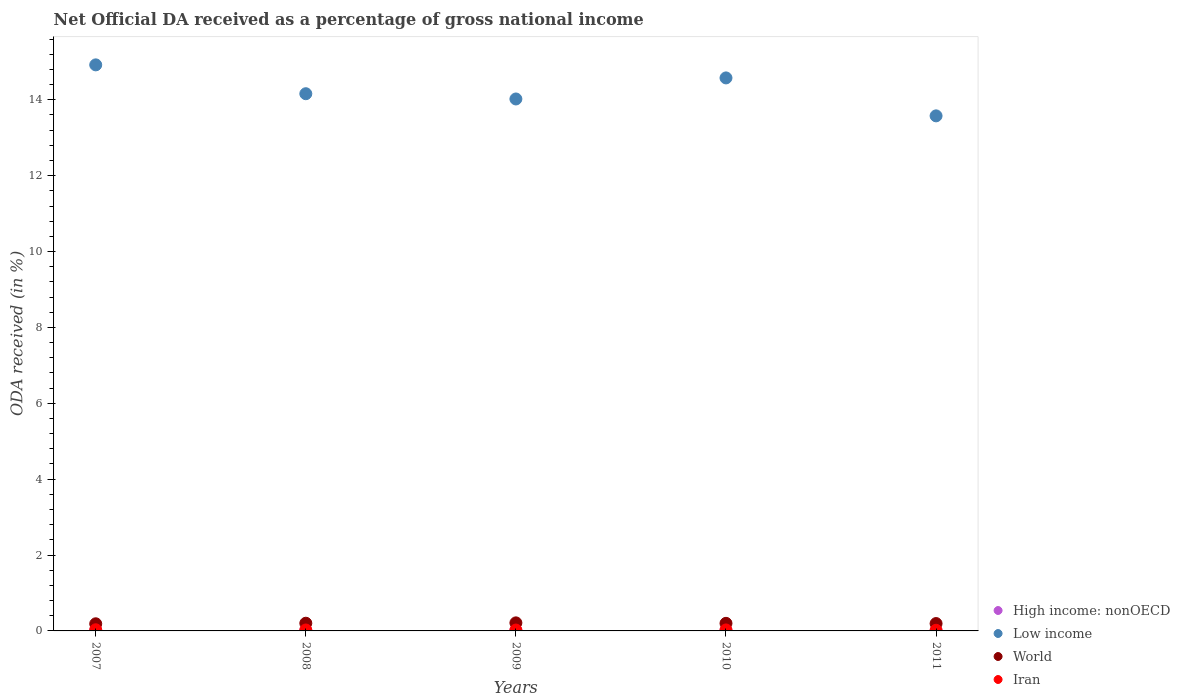What is the net official DA received in World in 2011?
Offer a very short reply. 0.19. Across all years, what is the maximum net official DA received in World?
Ensure brevity in your answer.  0.21. Across all years, what is the minimum net official DA received in High income: nonOECD?
Your response must be concise. 0. In which year was the net official DA received in Low income minimum?
Give a very brief answer. 2011. What is the total net official DA received in Low income in the graph?
Offer a very short reply. 71.26. What is the difference between the net official DA received in World in 2008 and that in 2011?
Your answer should be very brief. 0.01. What is the difference between the net official DA received in High income: nonOECD in 2011 and the net official DA received in World in 2009?
Give a very brief answer. -0.21. What is the average net official DA received in High income: nonOECD per year?
Ensure brevity in your answer.  0.01. In the year 2011, what is the difference between the net official DA received in Low income and net official DA received in World?
Make the answer very short. 13.38. What is the ratio of the net official DA received in Low income in 2010 to that in 2011?
Provide a succinct answer. 1.07. What is the difference between the highest and the second highest net official DA received in Iran?
Offer a very short reply. 0. What is the difference between the highest and the lowest net official DA received in World?
Your answer should be very brief. 0.02. In how many years, is the net official DA received in Low income greater than the average net official DA received in Low income taken over all years?
Offer a terse response. 2. Is it the case that in every year, the sum of the net official DA received in Iran and net official DA received in World  is greater than the net official DA received in High income: nonOECD?
Your answer should be compact. Yes. Does the net official DA received in World monotonically increase over the years?
Your answer should be compact. No. Is the net official DA received in High income: nonOECD strictly greater than the net official DA received in Low income over the years?
Your response must be concise. No. How many years are there in the graph?
Make the answer very short. 5. What is the difference between two consecutive major ticks on the Y-axis?
Provide a short and direct response. 2. Are the values on the major ticks of Y-axis written in scientific E-notation?
Your answer should be very brief. No. How many legend labels are there?
Offer a terse response. 4. How are the legend labels stacked?
Ensure brevity in your answer.  Vertical. What is the title of the graph?
Keep it short and to the point. Net Official DA received as a percentage of gross national income. What is the label or title of the X-axis?
Provide a succinct answer. Years. What is the label or title of the Y-axis?
Offer a terse response. ODA received (in %). What is the ODA received (in %) of High income: nonOECD in 2007?
Your answer should be compact. 0.01. What is the ODA received (in %) of Low income in 2007?
Your answer should be very brief. 14.92. What is the ODA received (in %) of World in 2007?
Provide a succinct answer. 0.19. What is the ODA received (in %) of Iran in 2007?
Offer a very short reply. 0.03. What is the ODA received (in %) in High income: nonOECD in 2008?
Give a very brief answer. 0.01. What is the ODA received (in %) in Low income in 2008?
Your response must be concise. 14.16. What is the ODA received (in %) of World in 2008?
Your response must be concise. 0.2. What is the ODA received (in %) of Iran in 2008?
Provide a succinct answer. 0.02. What is the ODA received (in %) of High income: nonOECD in 2009?
Ensure brevity in your answer.  0.02. What is the ODA received (in %) of Low income in 2009?
Offer a terse response. 14.02. What is the ODA received (in %) of World in 2009?
Offer a terse response. 0.21. What is the ODA received (in %) of Iran in 2009?
Offer a very short reply. 0.02. What is the ODA received (in %) in High income: nonOECD in 2010?
Offer a terse response. 0.01. What is the ODA received (in %) in Low income in 2010?
Provide a short and direct response. 14.58. What is the ODA received (in %) in World in 2010?
Your answer should be compact. 0.2. What is the ODA received (in %) of Iran in 2010?
Make the answer very short. 0.03. What is the ODA received (in %) of High income: nonOECD in 2011?
Make the answer very short. 0. What is the ODA received (in %) in Low income in 2011?
Keep it short and to the point. 13.58. What is the ODA received (in %) of World in 2011?
Make the answer very short. 0.19. What is the ODA received (in %) of Iran in 2011?
Your answer should be very brief. 0.02. Across all years, what is the maximum ODA received (in %) in High income: nonOECD?
Your answer should be very brief. 0.02. Across all years, what is the maximum ODA received (in %) in Low income?
Your answer should be very brief. 14.92. Across all years, what is the maximum ODA received (in %) of World?
Offer a very short reply. 0.21. Across all years, what is the maximum ODA received (in %) of Iran?
Provide a short and direct response. 0.03. Across all years, what is the minimum ODA received (in %) in High income: nonOECD?
Ensure brevity in your answer.  0. Across all years, what is the minimum ODA received (in %) of Low income?
Ensure brevity in your answer.  13.58. Across all years, what is the minimum ODA received (in %) in World?
Ensure brevity in your answer.  0.19. Across all years, what is the minimum ODA received (in %) in Iran?
Offer a very short reply. 0.02. What is the total ODA received (in %) in High income: nonOECD in the graph?
Offer a very short reply. 0.06. What is the total ODA received (in %) in Low income in the graph?
Ensure brevity in your answer.  71.26. What is the total ODA received (in %) in World in the graph?
Offer a very short reply. 1. What is the total ODA received (in %) of Iran in the graph?
Provide a succinct answer. 0.12. What is the difference between the ODA received (in %) of High income: nonOECD in 2007 and that in 2008?
Provide a succinct answer. 0. What is the difference between the ODA received (in %) in Low income in 2007 and that in 2008?
Ensure brevity in your answer.  0.76. What is the difference between the ODA received (in %) in World in 2007 and that in 2008?
Keep it short and to the point. -0.01. What is the difference between the ODA received (in %) in Iran in 2007 and that in 2008?
Offer a terse response. 0.01. What is the difference between the ODA received (in %) of High income: nonOECD in 2007 and that in 2009?
Keep it short and to the point. -0. What is the difference between the ODA received (in %) in Low income in 2007 and that in 2009?
Offer a very short reply. 0.9. What is the difference between the ODA received (in %) of World in 2007 and that in 2009?
Offer a very short reply. -0.02. What is the difference between the ODA received (in %) of Iran in 2007 and that in 2009?
Provide a succinct answer. 0.01. What is the difference between the ODA received (in %) of High income: nonOECD in 2007 and that in 2010?
Offer a very short reply. 0. What is the difference between the ODA received (in %) of Low income in 2007 and that in 2010?
Make the answer very short. 0.34. What is the difference between the ODA received (in %) in World in 2007 and that in 2010?
Provide a short and direct response. -0.01. What is the difference between the ODA received (in %) of Iran in 2007 and that in 2010?
Your answer should be very brief. 0. What is the difference between the ODA received (in %) in High income: nonOECD in 2007 and that in 2011?
Your response must be concise. 0.01. What is the difference between the ODA received (in %) of Low income in 2007 and that in 2011?
Your answer should be very brief. 1.34. What is the difference between the ODA received (in %) in World in 2007 and that in 2011?
Provide a succinct answer. -0.01. What is the difference between the ODA received (in %) in Iran in 2007 and that in 2011?
Provide a succinct answer. 0.01. What is the difference between the ODA received (in %) in High income: nonOECD in 2008 and that in 2009?
Ensure brevity in your answer.  -0. What is the difference between the ODA received (in %) in Low income in 2008 and that in 2009?
Provide a short and direct response. 0.14. What is the difference between the ODA received (in %) of World in 2008 and that in 2009?
Your response must be concise. -0.01. What is the difference between the ODA received (in %) in Iran in 2008 and that in 2009?
Your response must be concise. 0. What is the difference between the ODA received (in %) in High income: nonOECD in 2008 and that in 2010?
Provide a succinct answer. 0. What is the difference between the ODA received (in %) of Low income in 2008 and that in 2010?
Offer a very short reply. -0.42. What is the difference between the ODA received (in %) in World in 2008 and that in 2010?
Ensure brevity in your answer.  0. What is the difference between the ODA received (in %) in Iran in 2008 and that in 2010?
Ensure brevity in your answer.  -0. What is the difference between the ODA received (in %) in High income: nonOECD in 2008 and that in 2011?
Offer a very short reply. 0.01. What is the difference between the ODA received (in %) of Low income in 2008 and that in 2011?
Your answer should be very brief. 0.58. What is the difference between the ODA received (in %) in World in 2008 and that in 2011?
Provide a succinct answer. 0.01. What is the difference between the ODA received (in %) of Iran in 2008 and that in 2011?
Your response must be concise. 0.01. What is the difference between the ODA received (in %) of High income: nonOECD in 2009 and that in 2010?
Your answer should be very brief. 0. What is the difference between the ODA received (in %) in Low income in 2009 and that in 2010?
Provide a succinct answer. -0.56. What is the difference between the ODA received (in %) of World in 2009 and that in 2010?
Your answer should be very brief. 0.01. What is the difference between the ODA received (in %) in Iran in 2009 and that in 2010?
Offer a very short reply. -0. What is the difference between the ODA received (in %) of High income: nonOECD in 2009 and that in 2011?
Ensure brevity in your answer.  0.01. What is the difference between the ODA received (in %) of Low income in 2009 and that in 2011?
Your answer should be very brief. 0.45. What is the difference between the ODA received (in %) of World in 2009 and that in 2011?
Ensure brevity in your answer.  0.02. What is the difference between the ODA received (in %) in Iran in 2009 and that in 2011?
Your answer should be very brief. 0.01. What is the difference between the ODA received (in %) of High income: nonOECD in 2010 and that in 2011?
Your response must be concise. 0.01. What is the difference between the ODA received (in %) in World in 2010 and that in 2011?
Provide a short and direct response. 0.01. What is the difference between the ODA received (in %) in Iran in 2010 and that in 2011?
Make the answer very short. 0.01. What is the difference between the ODA received (in %) of High income: nonOECD in 2007 and the ODA received (in %) of Low income in 2008?
Give a very brief answer. -14.15. What is the difference between the ODA received (in %) in High income: nonOECD in 2007 and the ODA received (in %) in World in 2008?
Your answer should be compact. -0.19. What is the difference between the ODA received (in %) of High income: nonOECD in 2007 and the ODA received (in %) of Iran in 2008?
Your answer should be very brief. -0.01. What is the difference between the ODA received (in %) of Low income in 2007 and the ODA received (in %) of World in 2008?
Provide a succinct answer. 14.72. What is the difference between the ODA received (in %) of Low income in 2007 and the ODA received (in %) of Iran in 2008?
Ensure brevity in your answer.  14.9. What is the difference between the ODA received (in %) in World in 2007 and the ODA received (in %) in Iran in 2008?
Your answer should be compact. 0.16. What is the difference between the ODA received (in %) of High income: nonOECD in 2007 and the ODA received (in %) of Low income in 2009?
Your response must be concise. -14.01. What is the difference between the ODA received (in %) of High income: nonOECD in 2007 and the ODA received (in %) of World in 2009?
Provide a short and direct response. -0.2. What is the difference between the ODA received (in %) in High income: nonOECD in 2007 and the ODA received (in %) in Iran in 2009?
Offer a very short reply. -0.01. What is the difference between the ODA received (in %) of Low income in 2007 and the ODA received (in %) of World in 2009?
Offer a terse response. 14.71. What is the difference between the ODA received (in %) of Low income in 2007 and the ODA received (in %) of Iran in 2009?
Ensure brevity in your answer.  14.9. What is the difference between the ODA received (in %) in World in 2007 and the ODA received (in %) in Iran in 2009?
Offer a very short reply. 0.16. What is the difference between the ODA received (in %) of High income: nonOECD in 2007 and the ODA received (in %) of Low income in 2010?
Provide a short and direct response. -14.56. What is the difference between the ODA received (in %) of High income: nonOECD in 2007 and the ODA received (in %) of World in 2010?
Keep it short and to the point. -0.19. What is the difference between the ODA received (in %) in High income: nonOECD in 2007 and the ODA received (in %) in Iran in 2010?
Provide a short and direct response. -0.01. What is the difference between the ODA received (in %) of Low income in 2007 and the ODA received (in %) of World in 2010?
Provide a succinct answer. 14.72. What is the difference between the ODA received (in %) of Low income in 2007 and the ODA received (in %) of Iran in 2010?
Your response must be concise. 14.89. What is the difference between the ODA received (in %) in World in 2007 and the ODA received (in %) in Iran in 2010?
Your answer should be very brief. 0.16. What is the difference between the ODA received (in %) in High income: nonOECD in 2007 and the ODA received (in %) in Low income in 2011?
Keep it short and to the point. -13.56. What is the difference between the ODA received (in %) in High income: nonOECD in 2007 and the ODA received (in %) in World in 2011?
Your response must be concise. -0.18. What is the difference between the ODA received (in %) of High income: nonOECD in 2007 and the ODA received (in %) of Iran in 2011?
Keep it short and to the point. -0. What is the difference between the ODA received (in %) of Low income in 2007 and the ODA received (in %) of World in 2011?
Provide a succinct answer. 14.73. What is the difference between the ODA received (in %) of Low income in 2007 and the ODA received (in %) of Iran in 2011?
Provide a succinct answer. 14.9. What is the difference between the ODA received (in %) of World in 2007 and the ODA received (in %) of Iran in 2011?
Provide a short and direct response. 0.17. What is the difference between the ODA received (in %) in High income: nonOECD in 2008 and the ODA received (in %) in Low income in 2009?
Give a very brief answer. -14.01. What is the difference between the ODA received (in %) in High income: nonOECD in 2008 and the ODA received (in %) in World in 2009?
Ensure brevity in your answer.  -0.2. What is the difference between the ODA received (in %) in High income: nonOECD in 2008 and the ODA received (in %) in Iran in 2009?
Your answer should be compact. -0.01. What is the difference between the ODA received (in %) of Low income in 2008 and the ODA received (in %) of World in 2009?
Offer a very short reply. 13.95. What is the difference between the ODA received (in %) in Low income in 2008 and the ODA received (in %) in Iran in 2009?
Your answer should be very brief. 14.14. What is the difference between the ODA received (in %) of World in 2008 and the ODA received (in %) of Iran in 2009?
Your response must be concise. 0.18. What is the difference between the ODA received (in %) of High income: nonOECD in 2008 and the ODA received (in %) of Low income in 2010?
Your response must be concise. -14.56. What is the difference between the ODA received (in %) of High income: nonOECD in 2008 and the ODA received (in %) of World in 2010?
Give a very brief answer. -0.19. What is the difference between the ODA received (in %) in High income: nonOECD in 2008 and the ODA received (in %) in Iran in 2010?
Give a very brief answer. -0.01. What is the difference between the ODA received (in %) in Low income in 2008 and the ODA received (in %) in World in 2010?
Keep it short and to the point. 13.96. What is the difference between the ODA received (in %) of Low income in 2008 and the ODA received (in %) of Iran in 2010?
Provide a short and direct response. 14.13. What is the difference between the ODA received (in %) in World in 2008 and the ODA received (in %) in Iran in 2010?
Your answer should be compact. 0.18. What is the difference between the ODA received (in %) of High income: nonOECD in 2008 and the ODA received (in %) of Low income in 2011?
Your response must be concise. -13.56. What is the difference between the ODA received (in %) of High income: nonOECD in 2008 and the ODA received (in %) of World in 2011?
Make the answer very short. -0.18. What is the difference between the ODA received (in %) in High income: nonOECD in 2008 and the ODA received (in %) in Iran in 2011?
Offer a terse response. -0. What is the difference between the ODA received (in %) in Low income in 2008 and the ODA received (in %) in World in 2011?
Ensure brevity in your answer.  13.97. What is the difference between the ODA received (in %) in Low income in 2008 and the ODA received (in %) in Iran in 2011?
Your answer should be very brief. 14.14. What is the difference between the ODA received (in %) of World in 2008 and the ODA received (in %) of Iran in 2011?
Give a very brief answer. 0.19. What is the difference between the ODA received (in %) of High income: nonOECD in 2009 and the ODA received (in %) of Low income in 2010?
Provide a short and direct response. -14.56. What is the difference between the ODA received (in %) in High income: nonOECD in 2009 and the ODA received (in %) in World in 2010?
Provide a short and direct response. -0.18. What is the difference between the ODA received (in %) in High income: nonOECD in 2009 and the ODA received (in %) in Iran in 2010?
Provide a short and direct response. -0.01. What is the difference between the ODA received (in %) in Low income in 2009 and the ODA received (in %) in World in 2010?
Offer a terse response. 13.82. What is the difference between the ODA received (in %) in Low income in 2009 and the ODA received (in %) in Iran in 2010?
Your answer should be very brief. 14. What is the difference between the ODA received (in %) in World in 2009 and the ODA received (in %) in Iran in 2010?
Keep it short and to the point. 0.19. What is the difference between the ODA received (in %) of High income: nonOECD in 2009 and the ODA received (in %) of Low income in 2011?
Make the answer very short. -13.56. What is the difference between the ODA received (in %) in High income: nonOECD in 2009 and the ODA received (in %) in World in 2011?
Your answer should be very brief. -0.18. What is the difference between the ODA received (in %) in High income: nonOECD in 2009 and the ODA received (in %) in Iran in 2011?
Ensure brevity in your answer.  -0. What is the difference between the ODA received (in %) of Low income in 2009 and the ODA received (in %) of World in 2011?
Offer a very short reply. 13.83. What is the difference between the ODA received (in %) of Low income in 2009 and the ODA received (in %) of Iran in 2011?
Your answer should be compact. 14.01. What is the difference between the ODA received (in %) of World in 2009 and the ODA received (in %) of Iran in 2011?
Keep it short and to the point. 0.2. What is the difference between the ODA received (in %) in High income: nonOECD in 2010 and the ODA received (in %) in Low income in 2011?
Make the answer very short. -13.57. What is the difference between the ODA received (in %) in High income: nonOECD in 2010 and the ODA received (in %) in World in 2011?
Offer a very short reply. -0.18. What is the difference between the ODA received (in %) of High income: nonOECD in 2010 and the ODA received (in %) of Iran in 2011?
Keep it short and to the point. -0.01. What is the difference between the ODA received (in %) of Low income in 2010 and the ODA received (in %) of World in 2011?
Provide a short and direct response. 14.38. What is the difference between the ODA received (in %) of Low income in 2010 and the ODA received (in %) of Iran in 2011?
Give a very brief answer. 14.56. What is the difference between the ODA received (in %) of World in 2010 and the ODA received (in %) of Iran in 2011?
Your response must be concise. 0.18. What is the average ODA received (in %) in High income: nonOECD per year?
Provide a succinct answer. 0.01. What is the average ODA received (in %) in Low income per year?
Ensure brevity in your answer.  14.25. What is the average ODA received (in %) in World per year?
Your answer should be compact. 0.2. What is the average ODA received (in %) in Iran per year?
Provide a short and direct response. 0.02. In the year 2007, what is the difference between the ODA received (in %) of High income: nonOECD and ODA received (in %) of Low income?
Give a very brief answer. -14.91. In the year 2007, what is the difference between the ODA received (in %) in High income: nonOECD and ODA received (in %) in World?
Your answer should be compact. -0.17. In the year 2007, what is the difference between the ODA received (in %) in High income: nonOECD and ODA received (in %) in Iran?
Provide a short and direct response. -0.02. In the year 2007, what is the difference between the ODA received (in %) in Low income and ODA received (in %) in World?
Ensure brevity in your answer.  14.73. In the year 2007, what is the difference between the ODA received (in %) of Low income and ODA received (in %) of Iran?
Ensure brevity in your answer.  14.89. In the year 2007, what is the difference between the ODA received (in %) in World and ODA received (in %) in Iran?
Provide a short and direct response. 0.16. In the year 2008, what is the difference between the ODA received (in %) of High income: nonOECD and ODA received (in %) of Low income?
Your answer should be compact. -14.15. In the year 2008, what is the difference between the ODA received (in %) in High income: nonOECD and ODA received (in %) in World?
Ensure brevity in your answer.  -0.19. In the year 2008, what is the difference between the ODA received (in %) in High income: nonOECD and ODA received (in %) in Iran?
Your response must be concise. -0.01. In the year 2008, what is the difference between the ODA received (in %) of Low income and ODA received (in %) of World?
Offer a very short reply. 13.96. In the year 2008, what is the difference between the ODA received (in %) in Low income and ODA received (in %) in Iran?
Offer a very short reply. 14.14. In the year 2008, what is the difference between the ODA received (in %) of World and ODA received (in %) of Iran?
Offer a terse response. 0.18. In the year 2009, what is the difference between the ODA received (in %) in High income: nonOECD and ODA received (in %) in Low income?
Offer a terse response. -14.01. In the year 2009, what is the difference between the ODA received (in %) of High income: nonOECD and ODA received (in %) of World?
Your answer should be very brief. -0.2. In the year 2009, what is the difference between the ODA received (in %) of High income: nonOECD and ODA received (in %) of Iran?
Make the answer very short. -0.01. In the year 2009, what is the difference between the ODA received (in %) of Low income and ODA received (in %) of World?
Your answer should be compact. 13.81. In the year 2009, what is the difference between the ODA received (in %) in Low income and ODA received (in %) in Iran?
Offer a terse response. 14. In the year 2009, what is the difference between the ODA received (in %) in World and ODA received (in %) in Iran?
Provide a short and direct response. 0.19. In the year 2010, what is the difference between the ODA received (in %) in High income: nonOECD and ODA received (in %) in Low income?
Offer a terse response. -14.57. In the year 2010, what is the difference between the ODA received (in %) of High income: nonOECD and ODA received (in %) of World?
Your answer should be very brief. -0.19. In the year 2010, what is the difference between the ODA received (in %) in High income: nonOECD and ODA received (in %) in Iran?
Your answer should be very brief. -0.01. In the year 2010, what is the difference between the ODA received (in %) of Low income and ODA received (in %) of World?
Your answer should be very brief. 14.38. In the year 2010, what is the difference between the ODA received (in %) in Low income and ODA received (in %) in Iran?
Provide a succinct answer. 14.55. In the year 2010, what is the difference between the ODA received (in %) in World and ODA received (in %) in Iran?
Provide a succinct answer. 0.17. In the year 2011, what is the difference between the ODA received (in %) in High income: nonOECD and ODA received (in %) in Low income?
Your answer should be very brief. -13.57. In the year 2011, what is the difference between the ODA received (in %) of High income: nonOECD and ODA received (in %) of World?
Your response must be concise. -0.19. In the year 2011, what is the difference between the ODA received (in %) of High income: nonOECD and ODA received (in %) of Iran?
Ensure brevity in your answer.  -0.01. In the year 2011, what is the difference between the ODA received (in %) of Low income and ODA received (in %) of World?
Offer a very short reply. 13.38. In the year 2011, what is the difference between the ODA received (in %) of Low income and ODA received (in %) of Iran?
Your response must be concise. 13.56. In the year 2011, what is the difference between the ODA received (in %) of World and ODA received (in %) of Iran?
Your answer should be compact. 0.18. What is the ratio of the ODA received (in %) in High income: nonOECD in 2007 to that in 2008?
Offer a terse response. 1.05. What is the ratio of the ODA received (in %) in Low income in 2007 to that in 2008?
Provide a succinct answer. 1.05. What is the ratio of the ODA received (in %) in World in 2007 to that in 2008?
Your answer should be very brief. 0.93. What is the ratio of the ODA received (in %) in Iran in 2007 to that in 2008?
Offer a very short reply. 1.23. What is the ratio of the ODA received (in %) in High income: nonOECD in 2007 to that in 2009?
Keep it short and to the point. 0.9. What is the ratio of the ODA received (in %) in Low income in 2007 to that in 2009?
Keep it short and to the point. 1.06. What is the ratio of the ODA received (in %) of World in 2007 to that in 2009?
Make the answer very short. 0.89. What is the ratio of the ODA received (in %) of Iran in 2007 to that in 2009?
Provide a succinct answer. 1.31. What is the ratio of the ODA received (in %) of High income: nonOECD in 2007 to that in 2010?
Give a very brief answer. 1.27. What is the ratio of the ODA received (in %) in Low income in 2007 to that in 2010?
Offer a terse response. 1.02. What is the ratio of the ODA received (in %) of World in 2007 to that in 2010?
Offer a very short reply. 0.94. What is the ratio of the ODA received (in %) of Iran in 2007 to that in 2010?
Provide a short and direct response. 1.17. What is the ratio of the ODA received (in %) in High income: nonOECD in 2007 to that in 2011?
Ensure brevity in your answer.  3.51. What is the ratio of the ODA received (in %) in Low income in 2007 to that in 2011?
Your answer should be compact. 1.1. What is the ratio of the ODA received (in %) of World in 2007 to that in 2011?
Offer a terse response. 0.97. What is the ratio of the ODA received (in %) of Iran in 2007 to that in 2011?
Offer a very short reply. 1.77. What is the ratio of the ODA received (in %) of High income: nonOECD in 2008 to that in 2009?
Ensure brevity in your answer.  0.86. What is the ratio of the ODA received (in %) in Low income in 2008 to that in 2009?
Keep it short and to the point. 1.01. What is the ratio of the ODA received (in %) of World in 2008 to that in 2009?
Ensure brevity in your answer.  0.95. What is the ratio of the ODA received (in %) of Iran in 2008 to that in 2009?
Provide a succinct answer. 1.07. What is the ratio of the ODA received (in %) of High income: nonOECD in 2008 to that in 2010?
Ensure brevity in your answer.  1.21. What is the ratio of the ODA received (in %) in Low income in 2008 to that in 2010?
Provide a short and direct response. 0.97. What is the ratio of the ODA received (in %) of World in 2008 to that in 2010?
Ensure brevity in your answer.  1.01. What is the ratio of the ODA received (in %) in Iran in 2008 to that in 2010?
Offer a very short reply. 0.95. What is the ratio of the ODA received (in %) of High income: nonOECD in 2008 to that in 2011?
Your answer should be compact. 3.35. What is the ratio of the ODA received (in %) of Low income in 2008 to that in 2011?
Your response must be concise. 1.04. What is the ratio of the ODA received (in %) in World in 2008 to that in 2011?
Keep it short and to the point. 1.04. What is the ratio of the ODA received (in %) of Iran in 2008 to that in 2011?
Offer a very short reply. 1.45. What is the ratio of the ODA received (in %) of High income: nonOECD in 2009 to that in 2010?
Provide a succinct answer. 1.4. What is the ratio of the ODA received (in %) in Low income in 2009 to that in 2010?
Ensure brevity in your answer.  0.96. What is the ratio of the ODA received (in %) in World in 2009 to that in 2010?
Make the answer very short. 1.06. What is the ratio of the ODA received (in %) in Iran in 2009 to that in 2010?
Your response must be concise. 0.89. What is the ratio of the ODA received (in %) in High income: nonOECD in 2009 to that in 2011?
Your response must be concise. 3.89. What is the ratio of the ODA received (in %) in Low income in 2009 to that in 2011?
Provide a short and direct response. 1.03. What is the ratio of the ODA received (in %) in World in 2009 to that in 2011?
Your response must be concise. 1.09. What is the ratio of the ODA received (in %) of Iran in 2009 to that in 2011?
Keep it short and to the point. 1.35. What is the ratio of the ODA received (in %) in High income: nonOECD in 2010 to that in 2011?
Offer a terse response. 2.77. What is the ratio of the ODA received (in %) in Low income in 2010 to that in 2011?
Make the answer very short. 1.07. What is the ratio of the ODA received (in %) of World in 2010 to that in 2011?
Provide a succinct answer. 1.03. What is the ratio of the ODA received (in %) of Iran in 2010 to that in 2011?
Offer a very short reply. 1.52. What is the difference between the highest and the second highest ODA received (in %) in High income: nonOECD?
Your response must be concise. 0. What is the difference between the highest and the second highest ODA received (in %) of Low income?
Provide a short and direct response. 0.34. What is the difference between the highest and the second highest ODA received (in %) in World?
Provide a succinct answer. 0.01. What is the difference between the highest and the second highest ODA received (in %) of Iran?
Your response must be concise. 0. What is the difference between the highest and the lowest ODA received (in %) in High income: nonOECD?
Keep it short and to the point. 0.01. What is the difference between the highest and the lowest ODA received (in %) of Low income?
Offer a terse response. 1.34. What is the difference between the highest and the lowest ODA received (in %) in World?
Offer a terse response. 0.02. What is the difference between the highest and the lowest ODA received (in %) of Iran?
Your answer should be very brief. 0.01. 